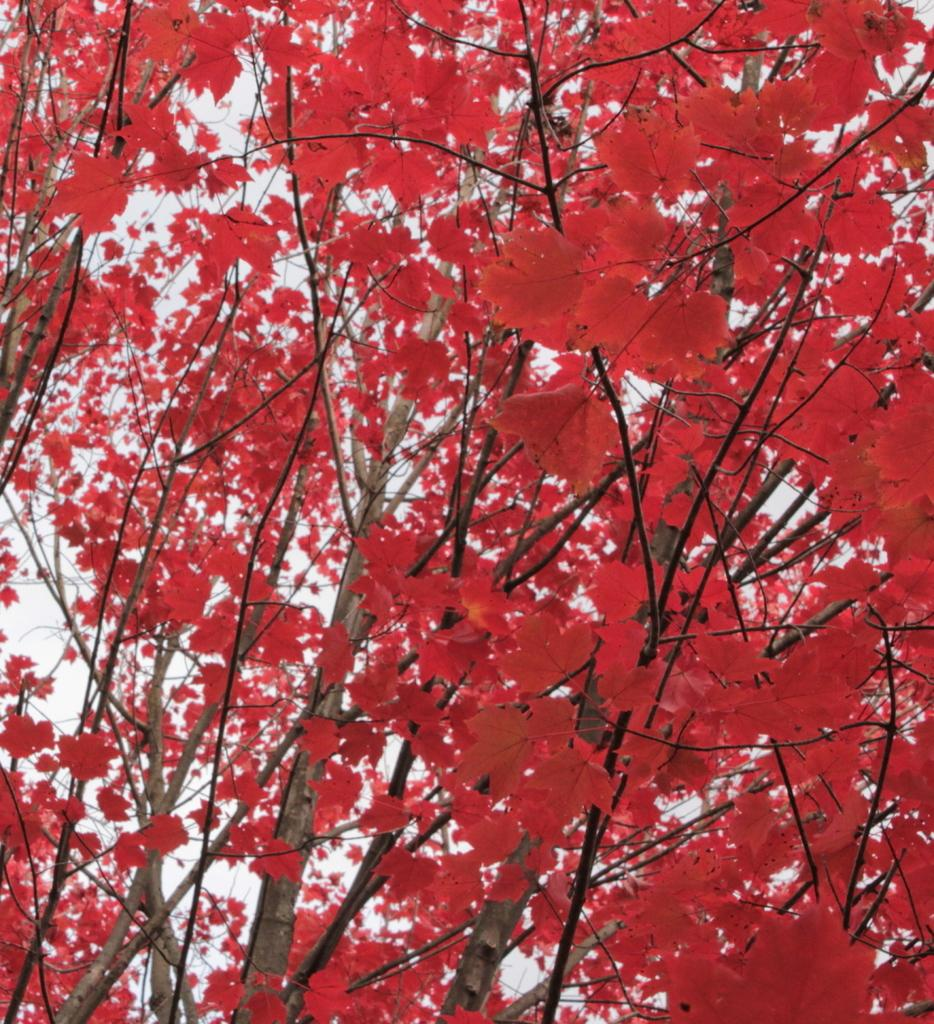What type of vegetation can be seen in the image? There are trees in the image. What part of the natural environment is visible in the image? The sky is visible in the image. How many feet are visible in the image? There are no feet present in the image; it features trees and the sky. What type of journey is depicted in the image? There is no journey depicted in the image; it simply shows trees and the sky. 